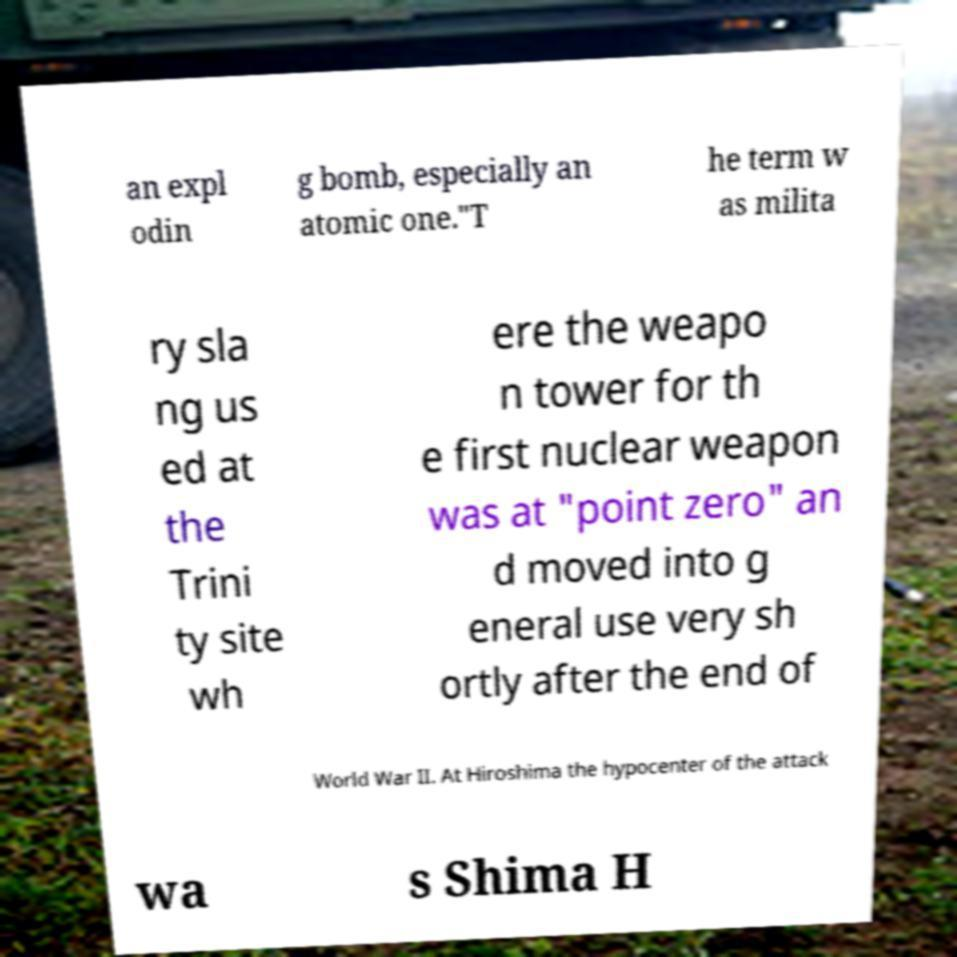Can you read and provide the text displayed in the image?This photo seems to have some interesting text. Can you extract and type it out for me? an expl odin g bomb, especially an atomic one."T he term w as milita ry sla ng us ed at the Trini ty site wh ere the weapo n tower for th e first nuclear weapon was at "point zero" an d moved into g eneral use very sh ortly after the end of World War II. At Hiroshima the hypocenter of the attack wa s Shima H 